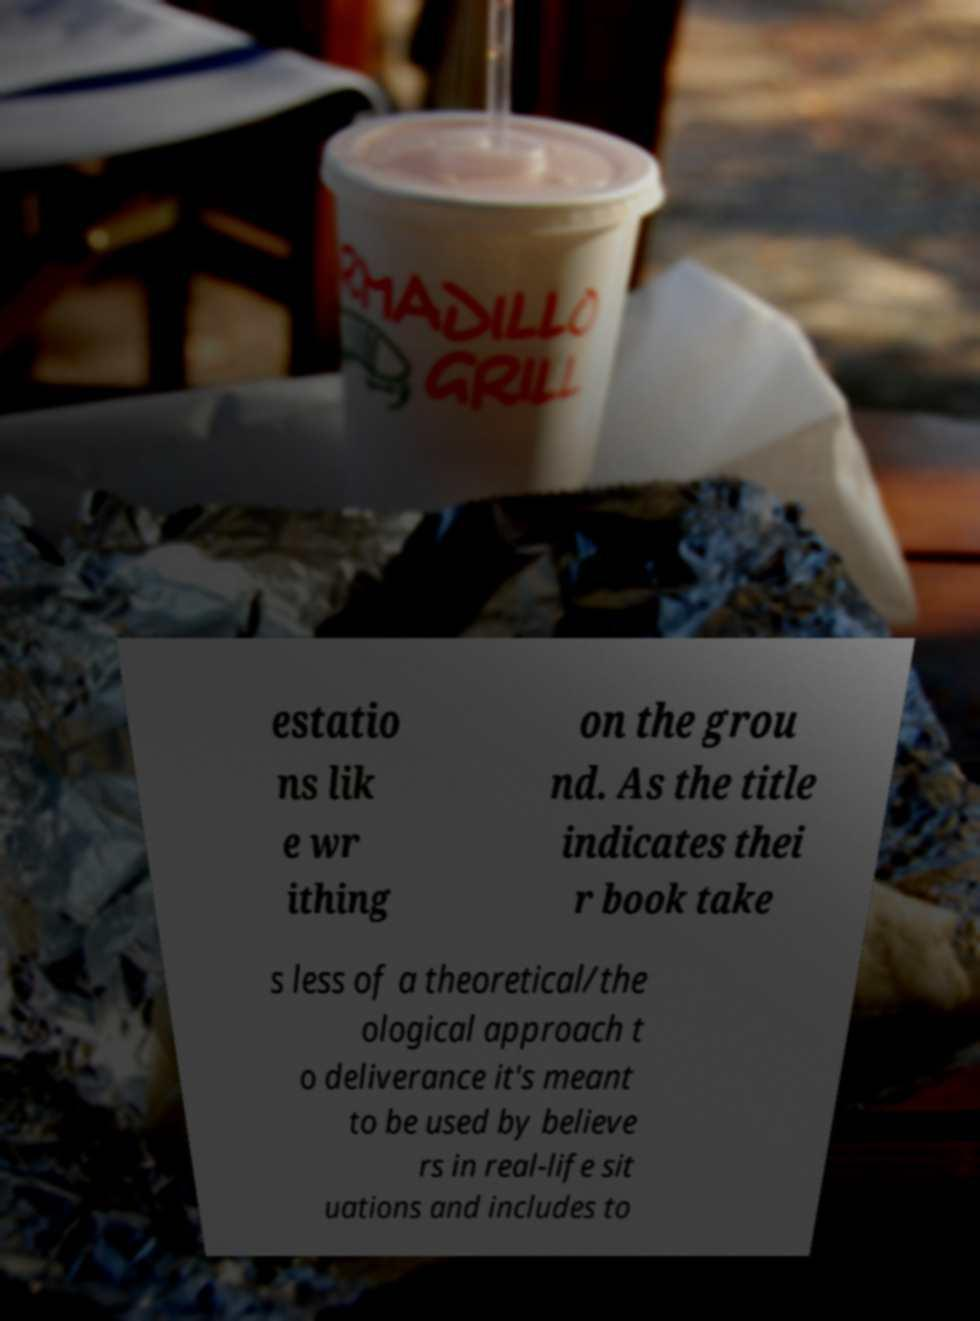There's text embedded in this image that I need extracted. Can you transcribe it verbatim? estatio ns lik e wr ithing on the grou nd. As the title indicates thei r book take s less of a theoretical/the ological approach t o deliverance it's meant to be used by believe rs in real-life sit uations and includes to 